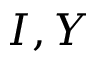<formula> <loc_0><loc_0><loc_500><loc_500>I , Y</formula> 